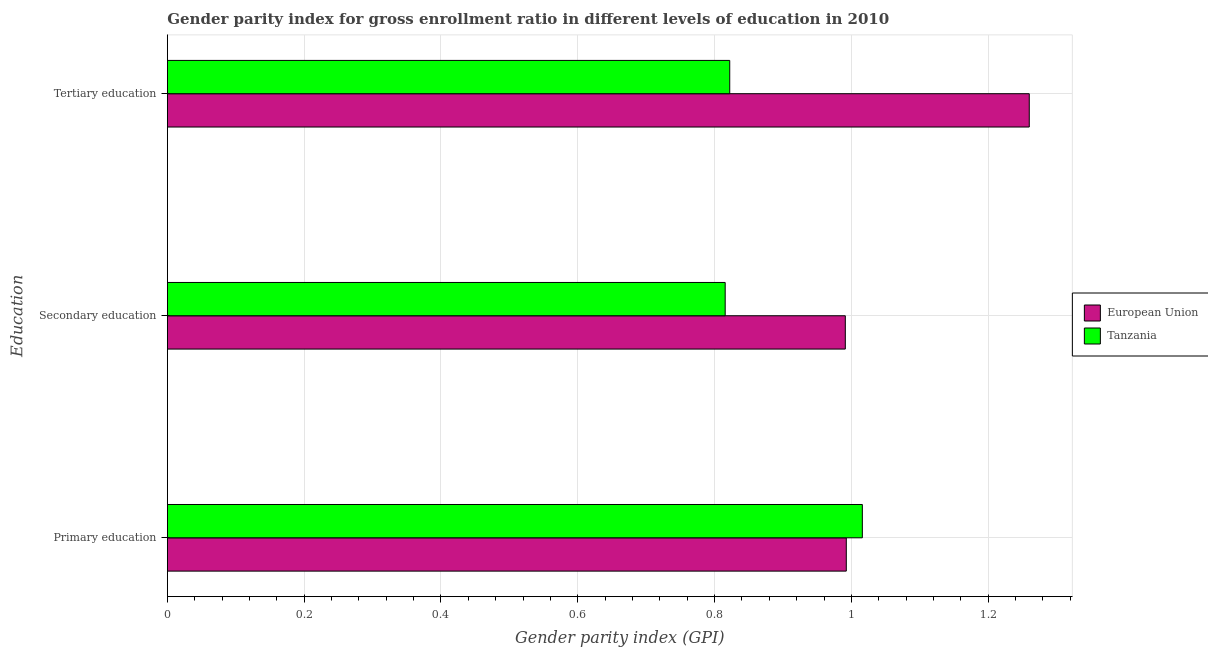How many different coloured bars are there?
Ensure brevity in your answer.  2. How many groups of bars are there?
Offer a terse response. 3. What is the gender parity index in secondary education in Tanzania?
Your answer should be very brief. 0.82. Across all countries, what is the maximum gender parity index in primary education?
Your answer should be compact. 1.02. Across all countries, what is the minimum gender parity index in primary education?
Make the answer very short. 0.99. What is the total gender parity index in primary education in the graph?
Offer a very short reply. 2.01. What is the difference between the gender parity index in primary education in European Union and that in Tanzania?
Ensure brevity in your answer.  -0.02. What is the difference between the gender parity index in tertiary education in European Union and the gender parity index in secondary education in Tanzania?
Offer a very short reply. 0.44. What is the average gender parity index in tertiary education per country?
Provide a succinct answer. 1.04. What is the difference between the gender parity index in primary education and gender parity index in secondary education in Tanzania?
Ensure brevity in your answer.  0.2. What is the ratio of the gender parity index in secondary education in European Union to that in Tanzania?
Your answer should be very brief. 1.22. Is the gender parity index in tertiary education in European Union less than that in Tanzania?
Your answer should be compact. No. Is the difference between the gender parity index in secondary education in European Union and Tanzania greater than the difference between the gender parity index in primary education in European Union and Tanzania?
Give a very brief answer. Yes. What is the difference between the highest and the second highest gender parity index in tertiary education?
Provide a short and direct response. 0.44. What is the difference between the highest and the lowest gender parity index in primary education?
Your response must be concise. 0.02. Is the sum of the gender parity index in primary education in European Union and Tanzania greater than the maximum gender parity index in secondary education across all countries?
Your answer should be compact. Yes. What does the 1st bar from the top in Tertiary education represents?
Your answer should be compact. Tanzania. What does the 2nd bar from the bottom in Tertiary education represents?
Your answer should be compact. Tanzania. Is it the case that in every country, the sum of the gender parity index in primary education and gender parity index in secondary education is greater than the gender parity index in tertiary education?
Ensure brevity in your answer.  Yes. How many bars are there?
Keep it short and to the point. 6. Are all the bars in the graph horizontal?
Your answer should be very brief. Yes. How many countries are there in the graph?
Give a very brief answer. 2. What is the difference between two consecutive major ticks on the X-axis?
Ensure brevity in your answer.  0.2. Are the values on the major ticks of X-axis written in scientific E-notation?
Give a very brief answer. No. Does the graph contain any zero values?
Offer a very short reply. No. How are the legend labels stacked?
Ensure brevity in your answer.  Vertical. What is the title of the graph?
Provide a succinct answer. Gender parity index for gross enrollment ratio in different levels of education in 2010. Does "Maldives" appear as one of the legend labels in the graph?
Your answer should be compact. No. What is the label or title of the X-axis?
Your answer should be very brief. Gender parity index (GPI). What is the label or title of the Y-axis?
Your answer should be very brief. Education. What is the Gender parity index (GPI) of European Union in Primary education?
Provide a succinct answer. 0.99. What is the Gender parity index (GPI) in Tanzania in Primary education?
Give a very brief answer. 1.02. What is the Gender parity index (GPI) of European Union in Secondary education?
Offer a terse response. 0.99. What is the Gender parity index (GPI) of Tanzania in Secondary education?
Offer a terse response. 0.82. What is the Gender parity index (GPI) in European Union in Tertiary education?
Offer a terse response. 1.26. What is the Gender parity index (GPI) in Tanzania in Tertiary education?
Your answer should be compact. 0.82. Across all Education, what is the maximum Gender parity index (GPI) of European Union?
Keep it short and to the point. 1.26. Across all Education, what is the maximum Gender parity index (GPI) in Tanzania?
Offer a very short reply. 1.02. Across all Education, what is the minimum Gender parity index (GPI) in European Union?
Make the answer very short. 0.99. Across all Education, what is the minimum Gender parity index (GPI) in Tanzania?
Your answer should be very brief. 0.82. What is the total Gender parity index (GPI) of European Union in the graph?
Offer a terse response. 3.24. What is the total Gender parity index (GPI) of Tanzania in the graph?
Offer a very short reply. 2.65. What is the difference between the Gender parity index (GPI) of European Union in Primary education and that in Secondary education?
Provide a succinct answer. 0. What is the difference between the Gender parity index (GPI) of Tanzania in Primary education and that in Secondary education?
Offer a very short reply. 0.2. What is the difference between the Gender parity index (GPI) in European Union in Primary education and that in Tertiary education?
Your answer should be very brief. -0.27. What is the difference between the Gender parity index (GPI) in Tanzania in Primary education and that in Tertiary education?
Your response must be concise. 0.19. What is the difference between the Gender parity index (GPI) of European Union in Secondary education and that in Tertiary education?
Offer a terse response. -0.27. What is the difference between the Gender parity index (GPI) of Tanzania in Secondary education and that in Tertiary education?
Make the answer very short. -0.01. What is the difference between the Gender parity index (GPI) of European Union in Primary education and the Gender parity index (GPI) of Tanzania in Secondary education?
Provide a succinct answer. 0.18. What is the difference between the Gender parity index (GPI) of European Union in Primary education and the Gender parity index (GPI) of Tanzania in Tertiary education?
Offer a terse response. 0.17. What is the difference between the Gender parity index (GPI) in European Union in Secondary education and the Gender parity index (GPI) in Tanzania in Tertiary education?
Offer a very short reply. 0.17. What is the average Gender parity index (GPI) of European Union per Education?
Provide a short and direct response. 1.08. What is the average Gender parity index (GPI) in Tanzania per Education?
Make the answer very short. 0.88. What is the difference between the Gender parity index (GPI) in European Union and Gender parity index (GPI) in Tanzania in Primary education?
Provide a succinct answer. -0.02. What is the difference between the Gender parity index (GPI) of European Union and Gender parity index (GPI) of Tanzania in Secondary education?
Ensure brevity in your answer.  0.18. What is the difference between the Gender parity index (GPI) in European Union and Gender parity index (GPI) in Tanzania in Tertiary education?
Provide a short and direct response. 0.44. What is the ratio of the Gender parity index (GPI) in Tanzania in Primary education to that in Secondary education?
Offer a terse response. 1.25. What is the ratio of the Gender parity index (GPI) in European Union in Primary education to that in Tertiary education?
Ensure brevity in your answer.  0.79. What is the ratio of the Gender parity index (GPI) in Tanzania in Primary education to that in Tertiary education?
Make the answer very short. 1.24. What is the ratio of the Gender parity index (GPI) of European Union in Secondary education to that in Tertiary education?
Offer a terse response. 0.79. What is the ratio of the Gender parity index (GPI) in Tanzania in Secondary education to that in Tertiary education?
Keep it short and to the point. 0.99. What is the difference between the highest and the second highest Gender parity index (GPI) of European Union?
Your answer should be very brief. 0.27. What is the difference between the highest and the second highest Gender parity index (GPI) in Tanzania?
Your answer should be compact. 0.19. What is the difference between the highest and the lowest Gender parity index (GPI) of European Union?
Give a very brief answer. 0.27. What is the difference between the highest and the lowest Gender parity index (GPI) in Tanzania?
Offer a terse response. 0.2. 